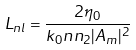Convert formula to latex. <formula><loc_0><loc_0><loc_500><loc_500>L _ { n l } = \frac { 2 \eta _ { 0 } } { k _ { 0 } n n _ { 2 } | A _ { m } | ^ { 2 } }</formula> 